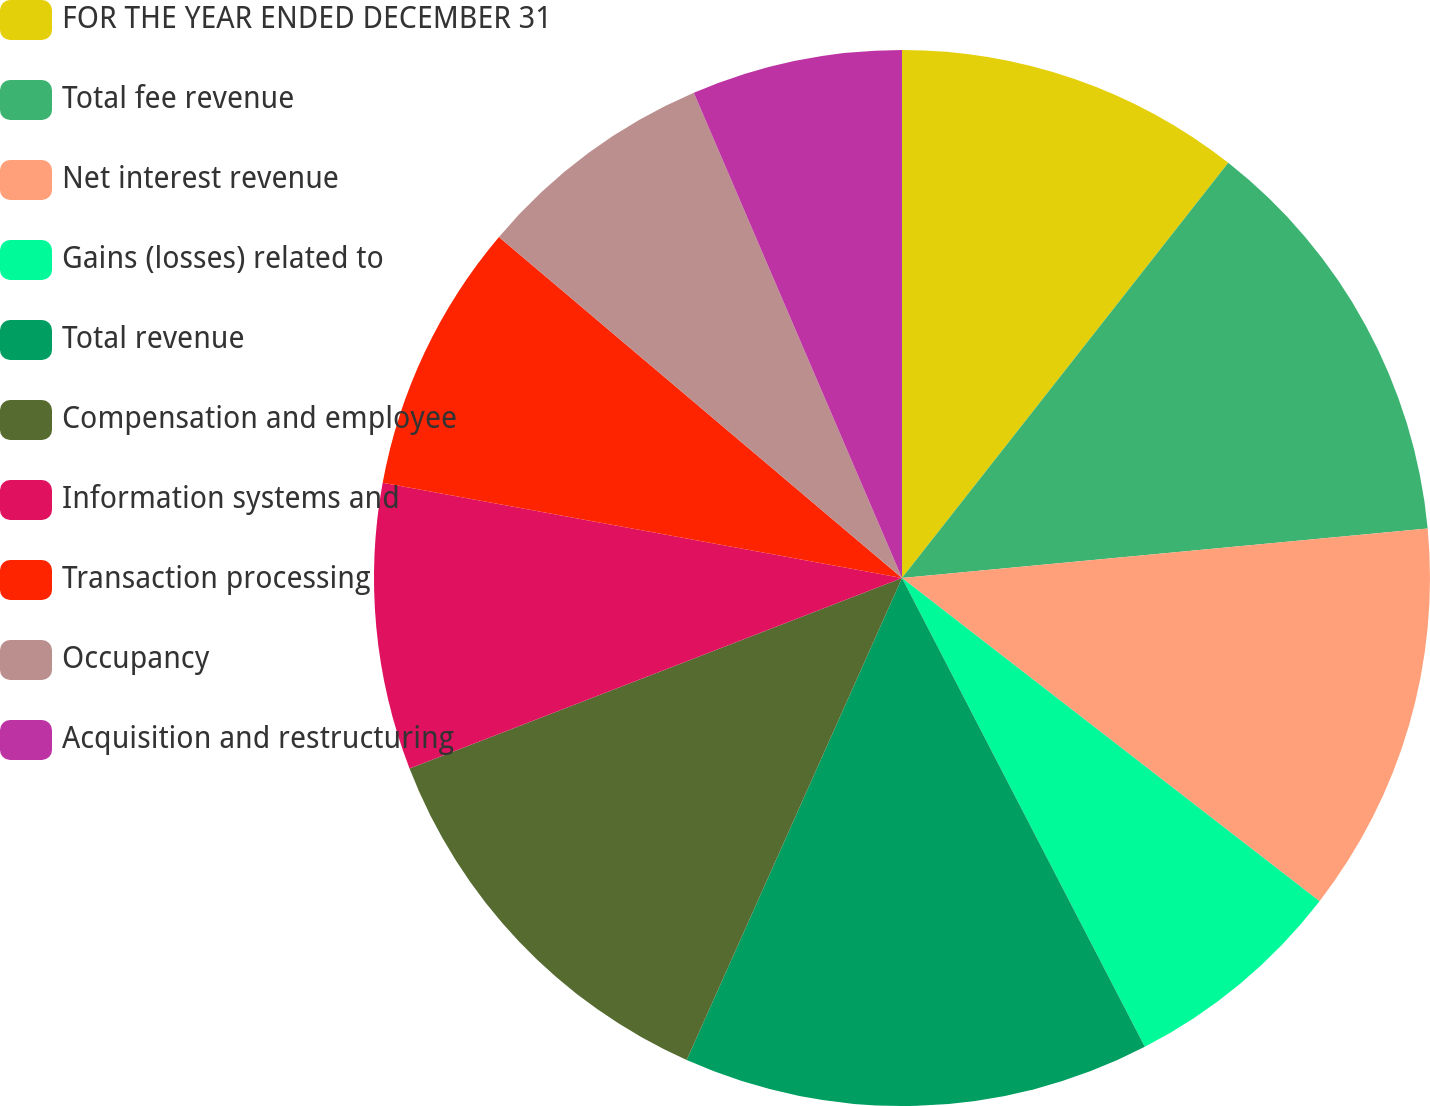Convert chart. <chart><loc_0><loc_0><loc_500><loc_500><pie_chart><fcel>FOR THE YEAR ENDED DECEMBER 31<fcel>Total fee revenue<fcel>Net interest revenue<fcel>Gains (losses) related to<fcel>Total revenue<fcel>Compensation and employee<fcel>Information systems and<fcel>Transaction processing<fcel>Occupancy<fcel>Acquisition and restructuring<nl><fcel>10.6%<fcel>12.9%<fcel>11.98%<fcel>6.91%<fcel>14.29%<fcel>12.44%<fcel>8.76%<fcel>8.29%<fcel>7.37%<fcel>6.45%<nl></chart> 